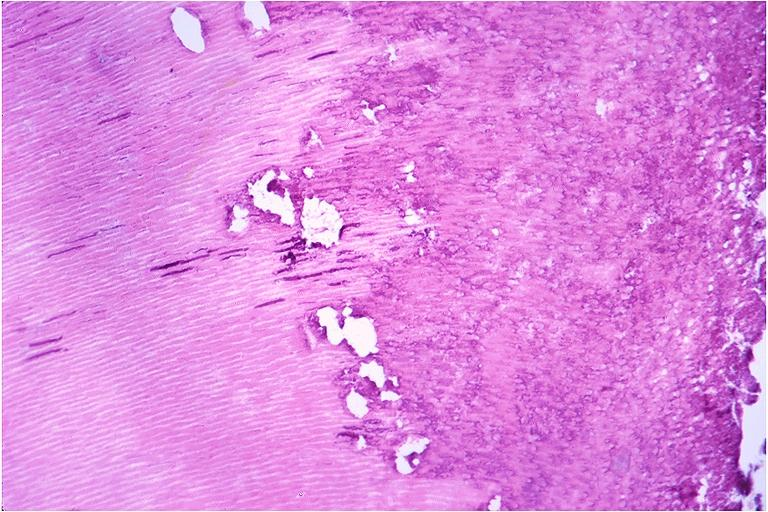does leiomyoma show caries?
Answer the question using a single word or phrase. No 